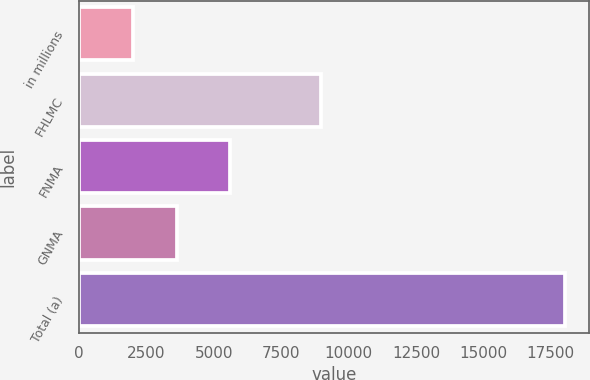<chart> <loc_0><loc_0><loc_500><loc_500><bar_chart><fcel>in millions<fcel>FHLMC<fcel>FNMA<fcel>GNMA<fcel>Total (a)<nl><fcel>2011<fcel>8984<fcel>5583<fcel>3613<fcel>18031<nl></chart> 